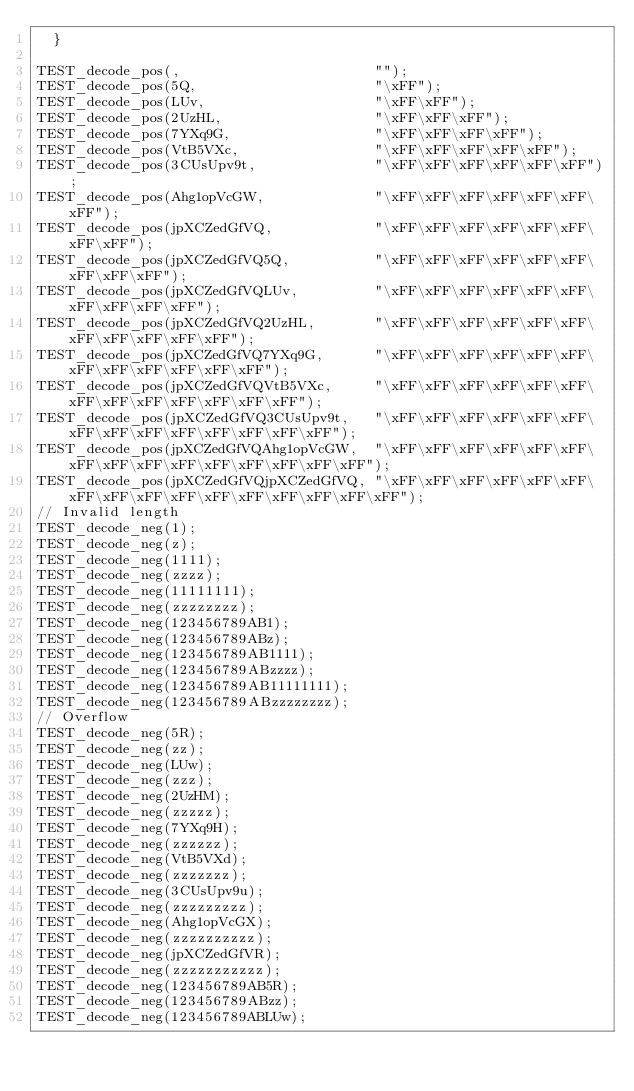Convert code to text. <code><loc_0><loc_0><loc_500><loc_500><_C++_>  }

TEST_decode_pos(,                       "");
TEST_decode_pos(5Q,                     "\xFF");
TEST_decode_pos(LUv,                    "\xFF\xFF");
TEST_decode_pos(2UzHL,                  "\xFF\xFF\xFF");
TEST_decode_pos(7YXq9G,                 "\xFF\xFF\xFF\xFF");
TEST_decode_pos(VtB5VXc,                "\xFF\xFF\xFF\xFF\xFF");
TEST_decode_pos(3CUsUpv9t,              "\xFF\xFF\xFF\xFF\xFF\xFF");
TEST_decode_pos(Ahg1opVcGW,             "\xFF\xFF\xFF\xFF\xFF\xFF\xFF");
TEST_decode_pos(jpXCZedGfVQ,            "\xFF\xFF\xFF\xFF\xFF\xFF\xFF\xFF");
TEST_decode_pos(jpXCZedGfVQ5Q,          "\xFF\xFF\xFF\xFF\xFF\xFF\xFF\xFF\xFF");
TEST_decode_pos(jpXCZedGfVQLUv,         "\xFF\xFF\xFF\xFF\xFF\xFF\xFF\xFF\xFF\xFF");
TEST_decode_pos(jpXCZedGfVQ2UzHL,       "\xFF\xFF\xFF\xFF\xFF\xFF\xFF\xFF\xFF\xFF\xFF");
TEST_decode_pos(jpXCZedGfVQ7YXq9G,      "\xFF\xFF\xFF\xFF\xFF\xFF\xFF\xFF\xFF\xFF\xFF\xFF");
TEST_decode_pos(jpXCZedGfVQVtB5VXc,     "\xFF\xFF\xFF\xFF\xFF\xFF\xFF\xFF\xFF\xFF\xFF\xFF\xFF");
TEST_decode_pos(jpXCZedGfVQ3CUsUpv9t,   "\xFF\xFF\xFF\xFF\xFF\xFF\xFF\xFF\xFF\xFF\xFF\xFF\xFF\xFF");
TEST_decode_pos(jpXCZedGfVQAhg1opVcGW,  "\xFF\xFF\xFF\xFF\xFF\xFF\xFF\xFF\xFF\xFF\xFF\xFF\xFF\xFF\xFF");
TEST_decode_pos(jpXCZedGfVQjpXCZedGfVQ, "\xFF\xFF\xFF\xFF\xFF\xFF\xFF\xFF\xFF\xFF\xFF\xFF\xFF\xFF\xFF\xFF");
// Invalid length
TEST_decode_neg(1);
TEST_decode_neg(z);
TEST_decode_neg(1111);
TEST_decode_neg(zzzz);
TEST_decode_neg(11111111);
TEST_decode_neg(zzzzzzzz);
TEST_decode_neg(123456789AB1);
TEST_decode_neg(123456789ABz);
TEST_decode_neg(123456789AB1111);
TEST_decode_neg(123456789ABzzzz);
TEST_decode_neg(123456789AB11111111);
TEST_decode_neg(123456789ABzzzzzzzz);
// Overflow
TEST_decode_neg(5R);
TEST_decode_neg(zz);
TEST_decode_neg(LUw);
TEST_decode_neg(zzz);
TEST_decode_neg(2UzHM);
TEST_decode_neg(zzzzz);
TEST_decode_neg(7YXq9H);
TEST_decode_neg(zzzzzz);
TEST_decode_neg(VtB5VXd);
TEST_decode_neg(zzzzzzz);
TEST_decode_neg(3CUsUpv9u);
TEST_decode_neg(zzzzzzzzz);
TEST_decode_neg(Ahg1opVcGX);
TEST_decode_neg(zzzzzzzzzz);
TEST_decode_neg(jpXCZedGfVR);
TEST_decode_neg(zzzzzzzzzzz);
TEST_decode_neg(123456789AB5R);
TEST_decode_neg(123456789ABzz);
TEST_decode_neg(123456789ABLUw);</code> 